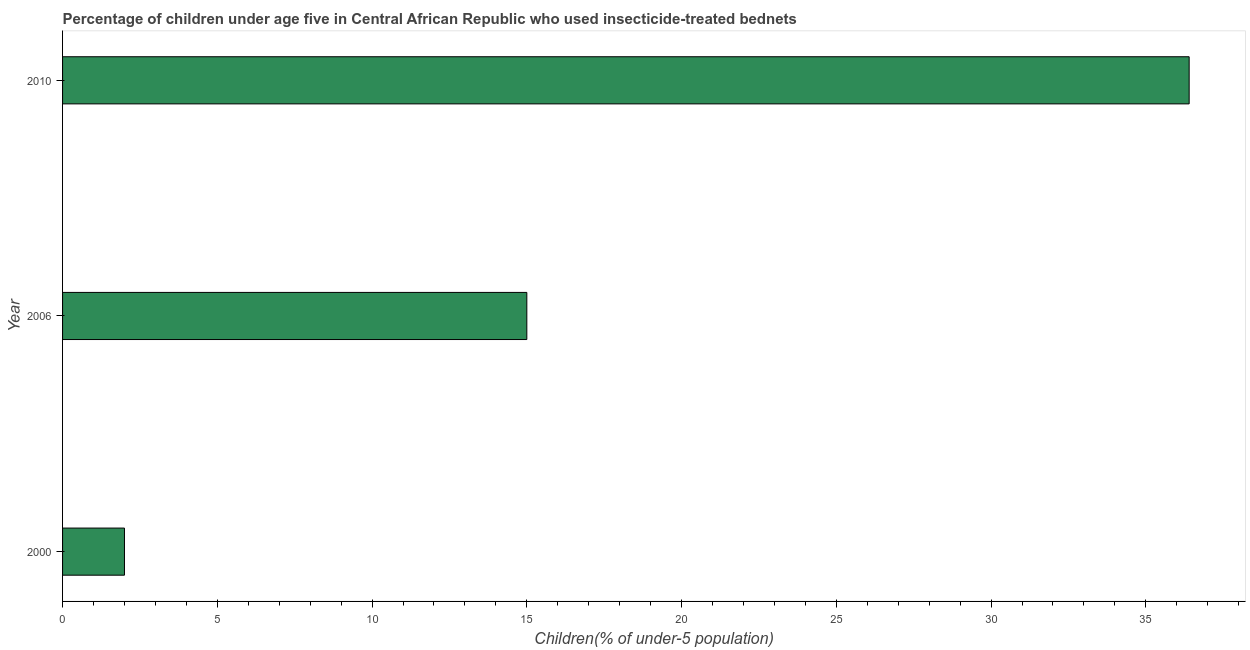What is the title of the graph?
Provide a succinct answer. Percentage of children under age five in Central African Republic who used insecticide-treated bednets. What is the label or title of the X-axis?
Keep it short and to the point. Children(% of under-5 population). Across all years, what is the maximum percentage of children who use of insecticide-treated bed nets?
Offer a very short reply. 36.4. In which year was the percentage of children who use of insecticide-treated bed nets maximum?
Offer a very short reply. 2010. In which year was the percentage of children who use of insecticide-treated bed nets minimum?
Ensure brevity in your answer.  2000. What is the sum of the percentage of children who use of insecticide-treated bed nets?
Provide a succinct answer. 53.4. What is the difference between the percentage of children who use of insecticide-treated bed nets in 2000 and 2006?
Offer a terse response. -13. Do a majority of the years between 2000 and 2006 (inclusive) have percentage of children who use of insecticide-treated bed nets greater than 28 %?
Your answer should be compact. No. What is the ratio of the percentage of children who use of insecticide-treated bed nets in 2000 to that in 2010?
Offer a terse response. 0.06. What is the difference between the highest and the second highest percentage of children who use of insecticide-treated bed nets?
Make the answer very short. 21.4. Is the sum of the percentage of children who use of insecticide-treated bed nets in 2000 and 2006 greater than the maximum percentage of children who use of insecticide-treated bed nets across all years?
Your answer should be very brief. No. What is the difference between the highest and the lowest percentage of children who use of insecticide-treated bed nets?
Your answer should be compact. 34.4. Are all the bars in the graph horizontal?
Offer a very short reply. Yes. Are the values on the major ticks of X-axis written in scientific E-notation?
Your response must be concise. No. What is the Children(% of under-5 population) of 2010?
Your answer should be compact. 36.4. What is the difference between the Children(% of under-5 population) in 2000 and 2006?
Offer a very short reply. -13. What is the difference between the Children(% of under-5 population) in 2000 and 2010?
Offer a terse response. -34.4. What is the difference between the Children(% of under-5 population) in 2006 and 2010?
Your answer should be very brief. -21.4. What is the ratio of the Children(% of under-5 population) in 2000 to that in 2006?
Make the answer very short. 0.13. What is the ratio of the Children(% of under-5 population) in 2000 to that in 2010?
Give a very brief answer. 0.06. What is the ratio of the Children(% of under-5 population) in 2006 to that in 2010?
Give a very brief answer. 0.41. 